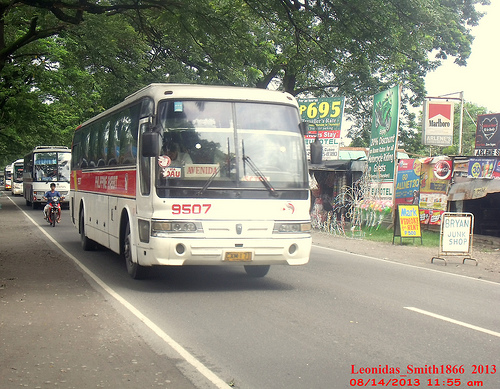Please provide a short description for this region: [0.01, 0.4, 0.14, 0.52]. A row of white buses lined up on the street, moving slowly behind each other. 